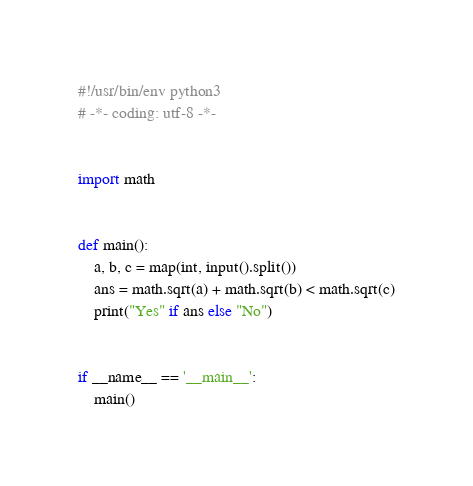Convert code to text. <code><loc_0><loc_0><loc_500><loc_500><_Python_>#!/usr/bin/env python3
# -*- coding: utf-8 -*-


import math


def main():
    a, b, c = map(int, input().split())
    ans = math.sqrt(a) + math.sqrt(b) < math.sqrt(c)
    print("Yes" if ans else "No")


if __name__ == '__main__':
    main()
</code> 